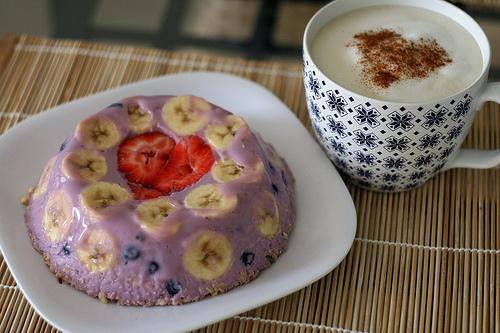Question: how many bananas slices are visible?
Choices:
A. 10.
B. 8.
C. 14.
D. 20.
Answer with the letter. Answer: C Question: what color is the yogurt?
Choices:
A. Pink.
B. Orange.
C. White.
D. Purple.
Answer with the letter. Answer: D Question: what color is the plate?
Choices:
A. Red.
B. Blue.
C. Yellow.
D. White.
Answer with the letter. Answer: D Question: when will this be eaten?
Choices:
A. Lunch.
B. Snack.
C. Breakfast.
D. Dinner.
Answer with the letter. Answer: C Question: where was this picture taken?
Choices:
A. Kitchen.
B. Dining room.
C. Bedroom.
D. Bathroom.
Answer with the letter. Answer: B Question: what shape do the strawberries make?
Choices:
A. Square.
B. Circle.
C. Heart.
D. Rectangle.
Answer with the letter. Answer: C 